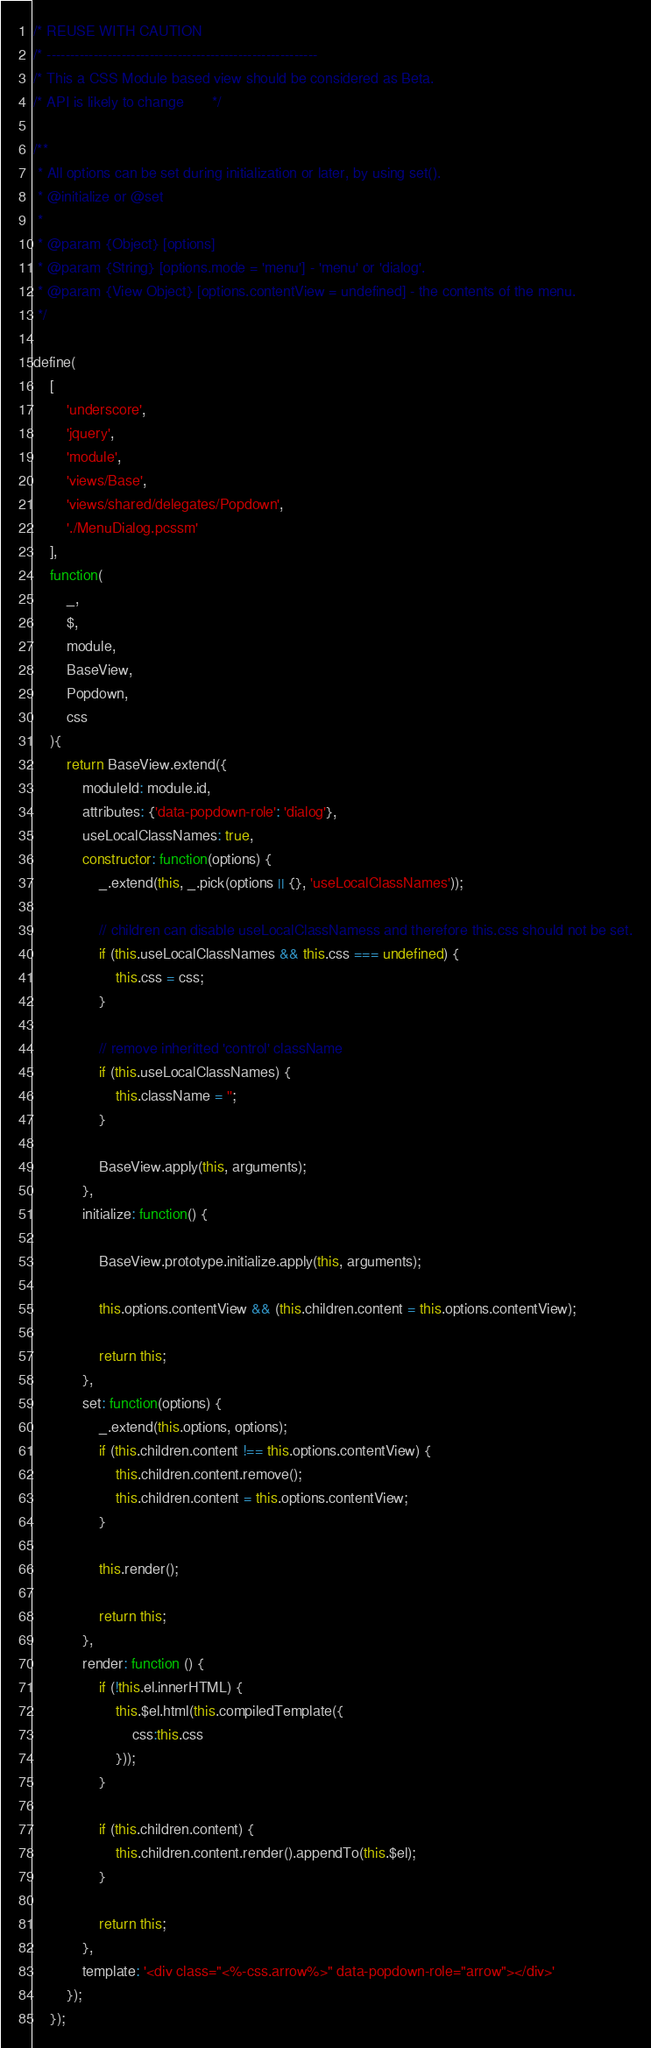<code> <loc_0><loc_0><loc_500><loc_500><_JavaScript_>/* REUSE WITH CAUTION
/* ----------------------------------------------------------
/* This a CSS Module based view should be considered as Beta.
/* API is likely to change       */

/**
 * All options can be set during initialization or later, by using set().
 * @initialize or @set
 *
 * @param {Object} [options]
 * @param {String} [options.mode = 'menu'] - 'menu' or 'dialog'.
 * @param {View Object} [options.contentView = undefined] - the contents of the menu.
 */

define(
    [
        'underscore',
        'jquery',
        'module',
        'views/Base',
        'views/shared/delegates/Popdown',
        './MenuDialog.pcssm'
    ],
    function(
        _,
        $,
        module,
        BaseView,
        Popdown,
        css
    ){
        return BaseView.extend({
            moduleId: module.id,
            attributes: {'data-popdown-role': 'dialog'},
            useLocalClassNames: true,
            constructor: function(options) {
                _.extend(this, _.pick(options || {}, 'useLocalClassNames'));

                // children can disable useLocalClassNamess and therefore this.css should not be set.
                if (this.useLocalClassNames && this.css === undefined) {
                    this.css = css;
                }

                // remove inheritted 'control' className
                if (this.useLocalClassNames) {
                    this.className = '';
                }

                BaseView.apply(this, arguments);
            },
            initialize: function() {

                BaseView.prototype.initialize.apply(this, arguments);

                this.options.contentView && (this.children.content = this.options.contentView);

                return this;
            },
            set: function(options) {
                _.extend(this.options, options);
                if (this.children.content !== this.options.contentView) {
                    this.children.content.remove();
                    this.children.content = this.options.contentView;
                }

                this.render();

                return this;
            },
            render: function () {
                if (!this.el.innerHTML) {
                    this.$el.html(this.compiledTemplate({
                        css:this.css
                    }));
                }

                if (this.children.content) {
                    this.children.content.render().appendTo(this.$el);
                }

                return this;
            },
            template: '<div class="<%-css.arrow%>" data-popdown-role="arrow"></div>'
        });
    });
</code> 